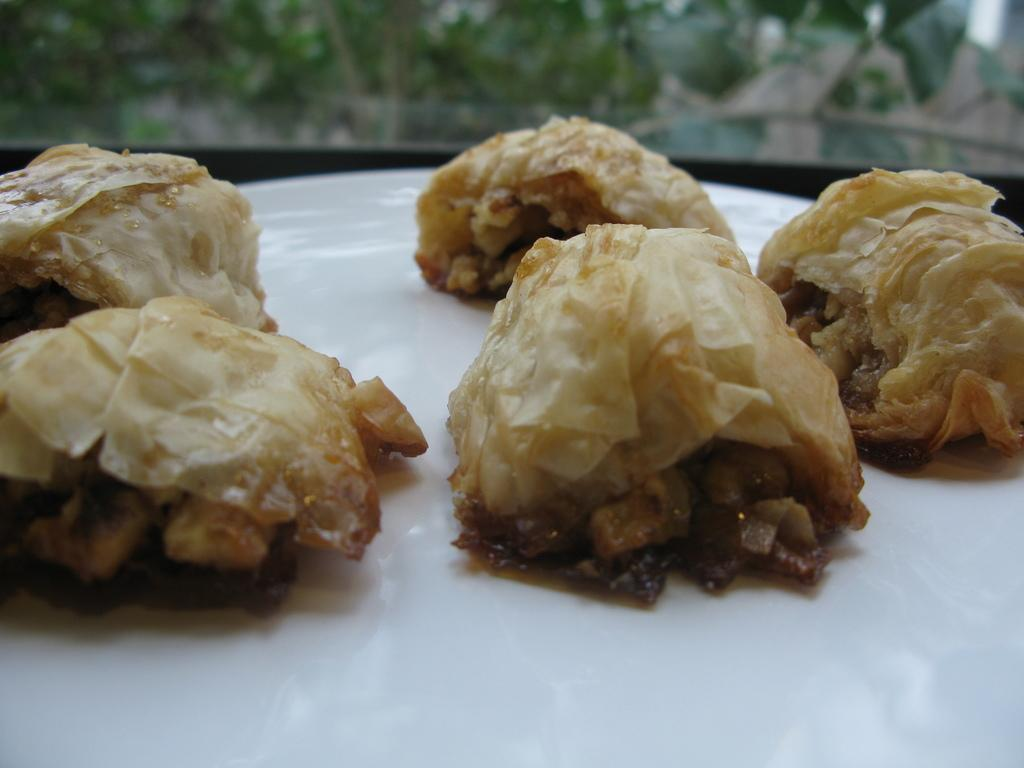What is present in the image related to eating? There is food in the image. How is the food arranged or presented? The food is placed on a plate. Is there a crown on top of the food in the image? No, there is no crown present in the image. 